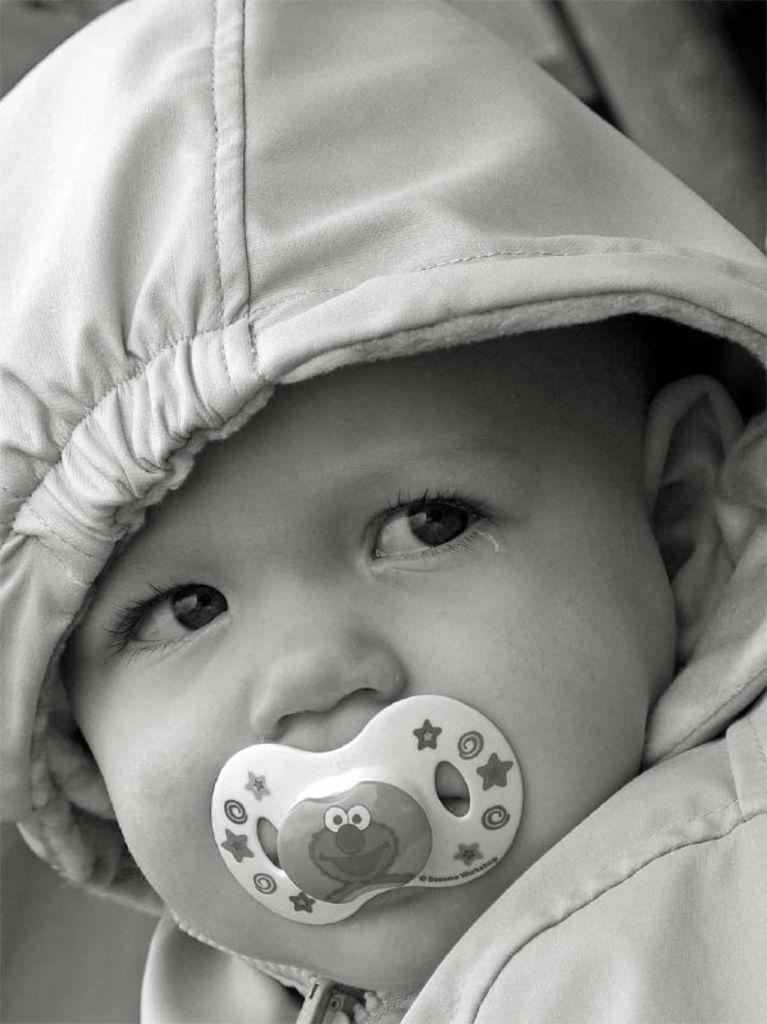Can you describe this image briefly? In this picture we can see an object, child, cloth and in the background it is blurry. 